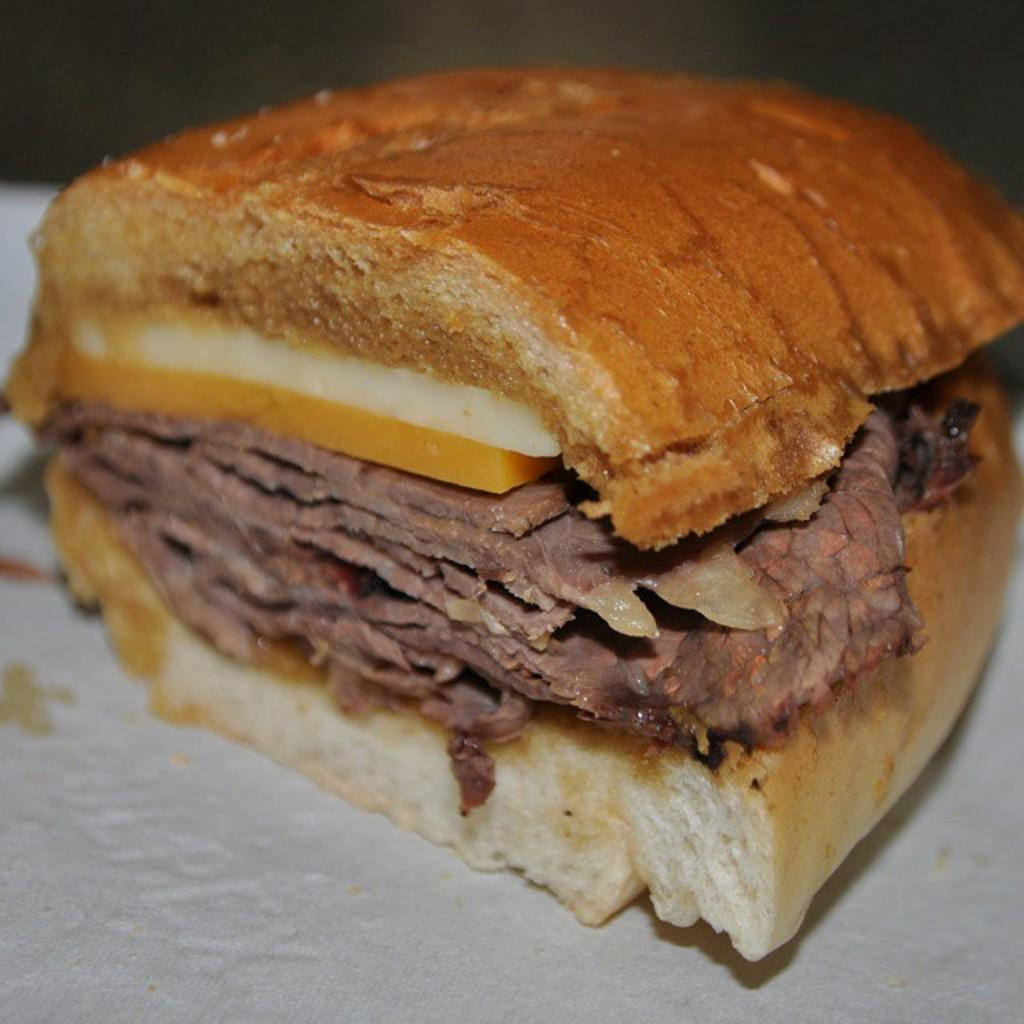What is the main subject of the image? There is a food item in the image. Where is the food item located? The food item is on a surface. What type of battle is taking place near the food item in the image? There is no battle present in the image; it only features a food item on a surface. How many borders can be seen surrounding the food item in the image? There are no borders visible in the image; it only features a food item on a surface. 